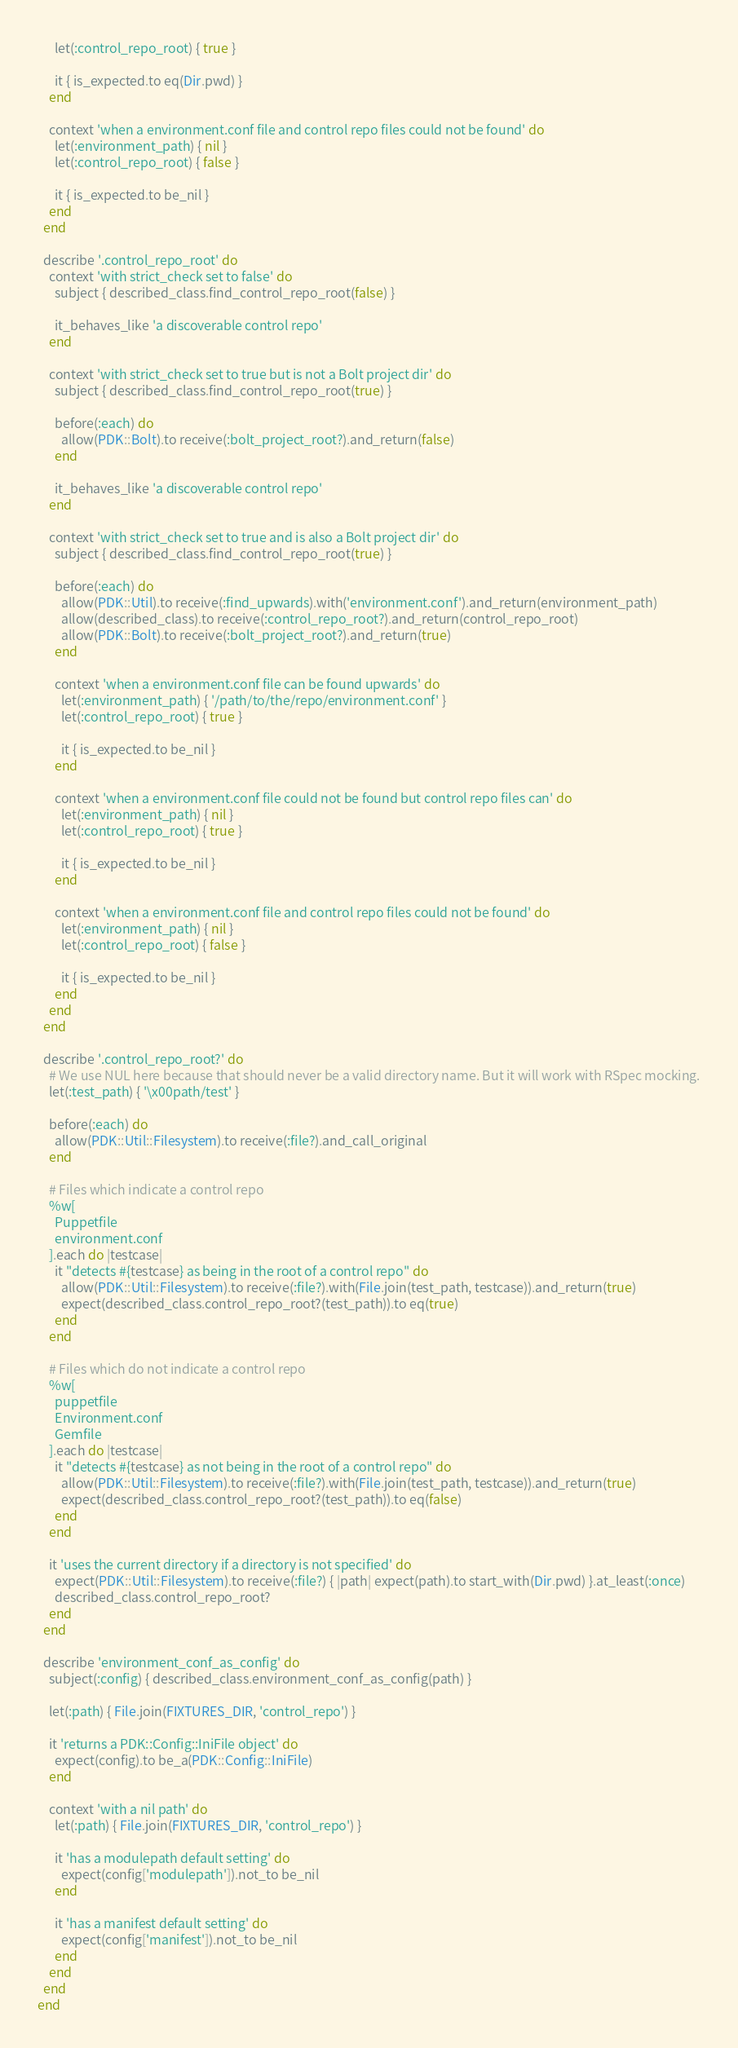Convert code to text. <code><loc_0><loc_0><loc_500><loc_500><_Ruby_>      let(:control_repo_root) { true }

      it { is_expected.to eq(Dir.pwd) }
    end

    context 'when a environment.conf file and control repo files could not be found' do
      let(:environment_path) { nil }
      let(:control_repo_root) { false }

      it { is_expected.to be_nil }
    end
  end

  describe '.control_repo_root' do
    context 'with strict_check set to false' do
      subject { described_class.find_control_repo_root(false) }

      it_behaves_like 'a discoverable control repo'
    end

    context 'with strict_check set to true but is not a Bolt project dir' do
      subject { described_class.find_control_repo_root(true) }

      before(:each) do
        allow(PDK::Bolt).to receive(:bolt_project_root?).and_return(false)
      end

      it_behaves_like 'a discoverable control repo'
    end

    context 'with strict_check set to true and is also a Bolt project dir' do
      subject { described_class.find_control_repo_root(true) }

      before(:each) do
        allow(PDK::Util).to receive(:find_upwards).with('environment.conf').and_return(environment_path)
        allow(described_class).to receive(:control_repo_root?).and_return(control_repo_root)
        allow(PDK::Bolt).to receive(:bolt_project_root?).and_return(true)
      end

      context 'when a environment.conf file can be found upwards' do
        let(:environment_path) { '/path/to/the/repo/environment.conf' }
        let(:control_repo_root) { true }

        it { is_expected.to be_nil }
      end

      context 'when a environment.conf file could not be found but control repo files can' do
        let(:environment_path) { nil }
        let(:control_repo_root) { true }

        it { is_expected.to be_nil }
      end

      context 'when a environment.conf file and control repo files could not be found' do
        let(:environment_path) { nil }
        let(:control_repo_root) { false }

        it { is_expected.to be_nil }
      end
    end
  end

  describe '.control_repo_root?' do
    # We use NUL here because that should never be a valid directory name. But it will work with RSpec mocking.
    let(:test_path) { '\x00path/test' }

    before(:each) do
      allow(PDK::Util::Filesystem).to receive(:file?).and_call_original
    end

    # Files which indicate a control repo
    %w[
      Puppetfile
      environment.conf
    ].each do |testcase|
      it "detects #{testcase} as being in the root of a control repo" do
        allow(PDK::Util::Filesystem).to receive(:file?).with(File.join(test_path, testcase)).and_return(true)
        expect(described_class.control_repo_root?(test_path)).to eq(true)
      end
    end

    # Files which do not indicate a control repo
    %w[
      puppetfile
      Environment.conf
      Gemfile
    ].each do |testcase|
      it "detects #{testcase} as not being in the root of a control repo" do
        allow(PDK::Util::Filesystem).to receive(:file?).with(File.join(test_path, testcase)).and_return(true)
        expect(described_class.control_repo_root?(test_path)).to eq(false)
      end
    end

    it 'uses the current directory if a directory is not specified' do
      expect(PDK::Util::Filesystem).to receive(:file?) { |path| expect(path).to start_with(Dir.pwd) }.at_least(:once)
      described_class.control_repo_root?
    end
  end

  describe 'environment_conf_as_config' do
    subject(:config) { described_class.environment_conf_as_config(path) }

    let(:path) { File.join(FIXTURES_DIR, 'control_repo') }

    it 'returns a PDK::Config::IniFile object' do
      expect(config).to be_a(PDK::Config::IniFile)
    end

    context 'with a nil path' do
      let(:path) { File.join(FIXTURES_DIR, 'control_repo') }

      it 'has a modulepath default setting' do
        expect(config['modulepath']).not_to be_nil
      end

      it 'has a manifest default setting' do
        expect(config['manifest']).not_to be_nil
      end
    end
  end
end
</code> 